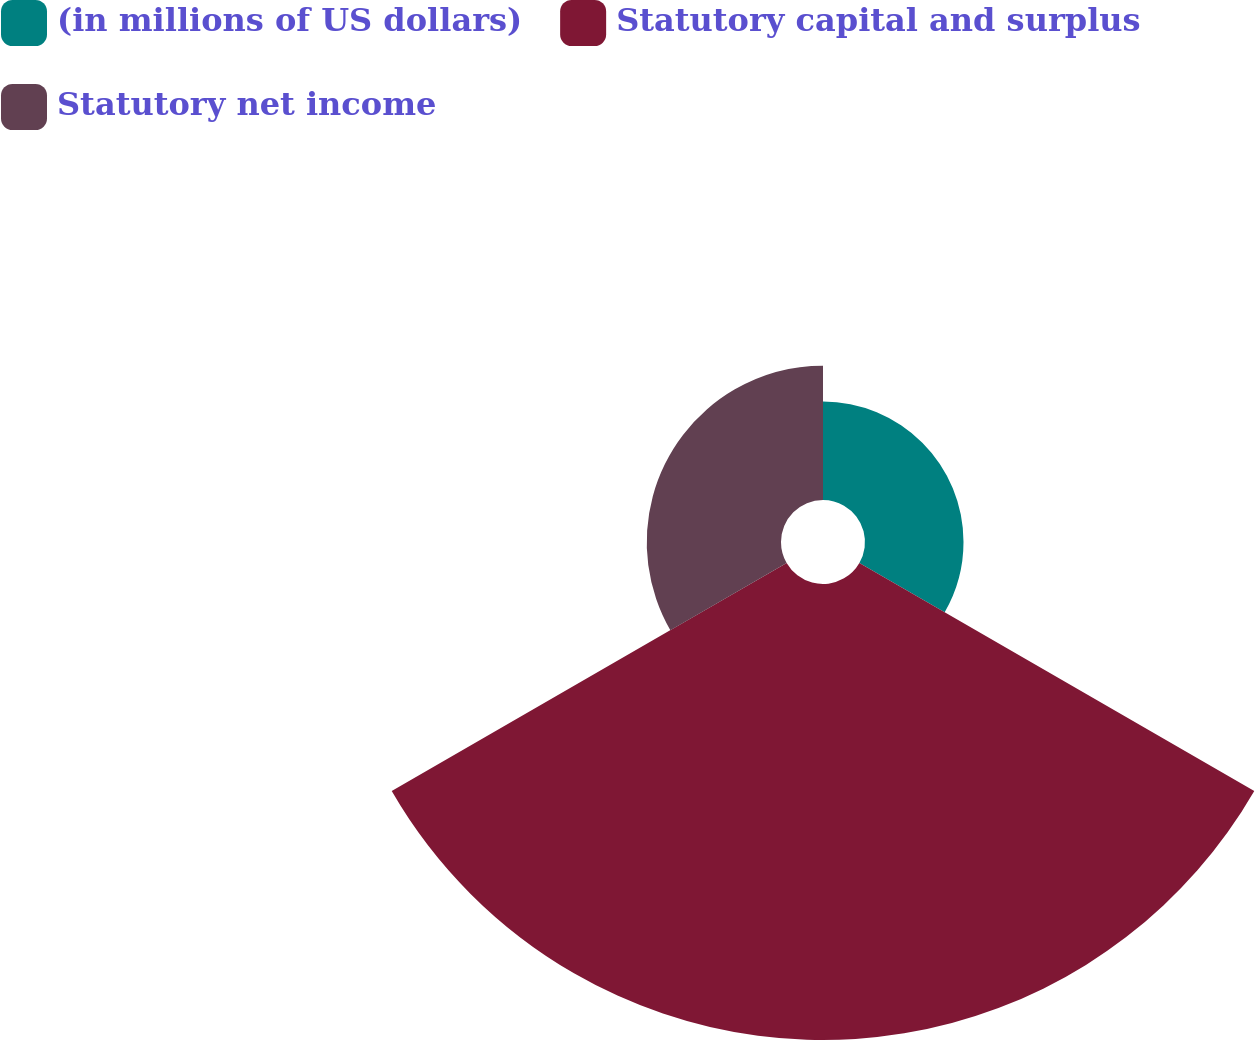Convert chart. <chart><loc_0><loc_0><loc_500><loc_500><pie_chart><fcel>(in millions of US dollars)<fcel>Statutory capital and surplus<fcel>Statutory net income<nl><fcel>14.3%<fcel>66.2%<fcel>19.49%<nl></chart> 